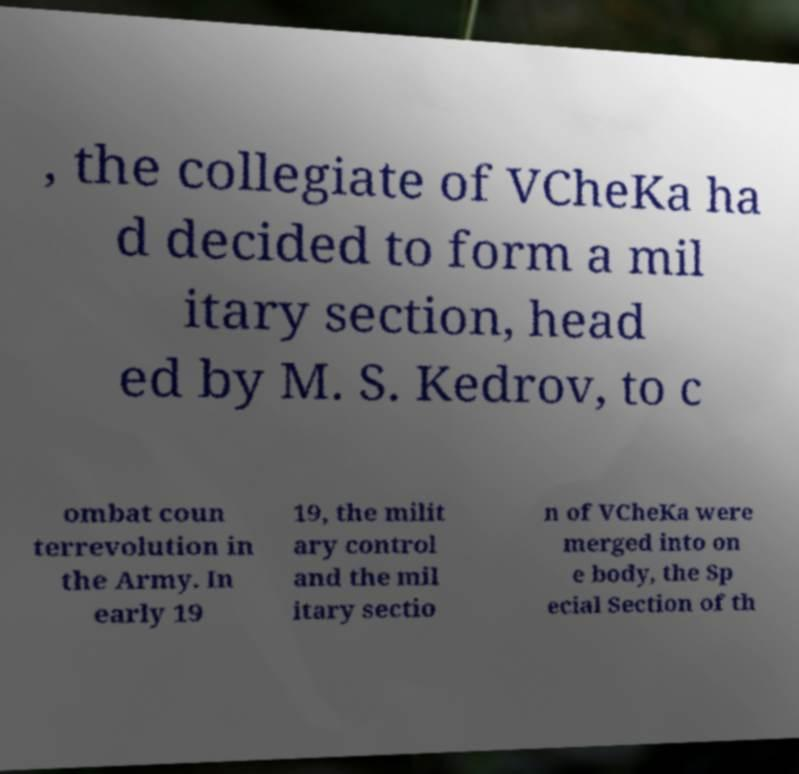Can you read and provide the text displayed in the image?This photo seems to have some interesting text. Can you extract and type it out for me? , the collegiate of VCheKa ha d decided to form a mil itary section, head ed by M. S. Kedrov, to c ombat coun terrevolution in the Army. In early 19 19, the milit ary control and the mil itary sectio n of VCheKa were merged into on e body, the Sp ecial Section of th 